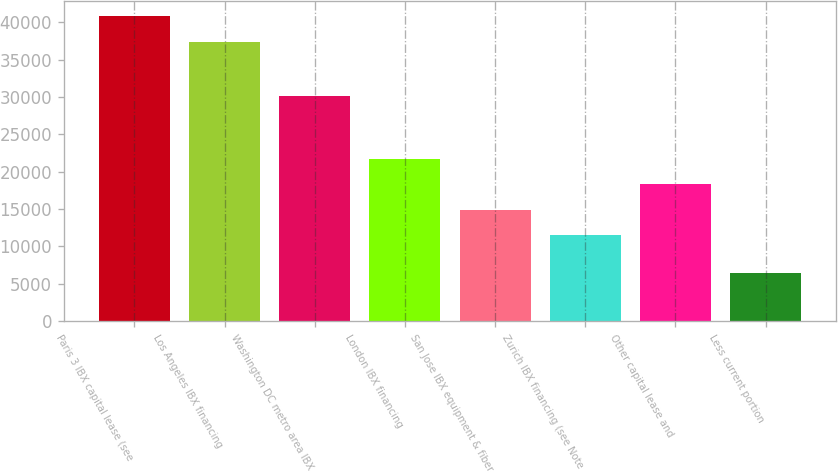<chart> <loc_0><loc_0><loc_500><loc_500><bar_chart><fcel>Paris 3 IBX capital lease (see<fcel>Los Angeles IBX financing<fcel>Washington DC metro area IBX<fcel>London IBX financing<fcel>San Jose IBX equipment & fiber<fcel>Zurich IBX financing (see Note<fcel>Other capital lease and<fcel>Less current portion<nl><fcel>40777.5<fcel>37363<fcel>30119<fcel>21713.5<fcel>14884.5<fcel>11470<fcel>18299<fcel>6452<nl></chart> 